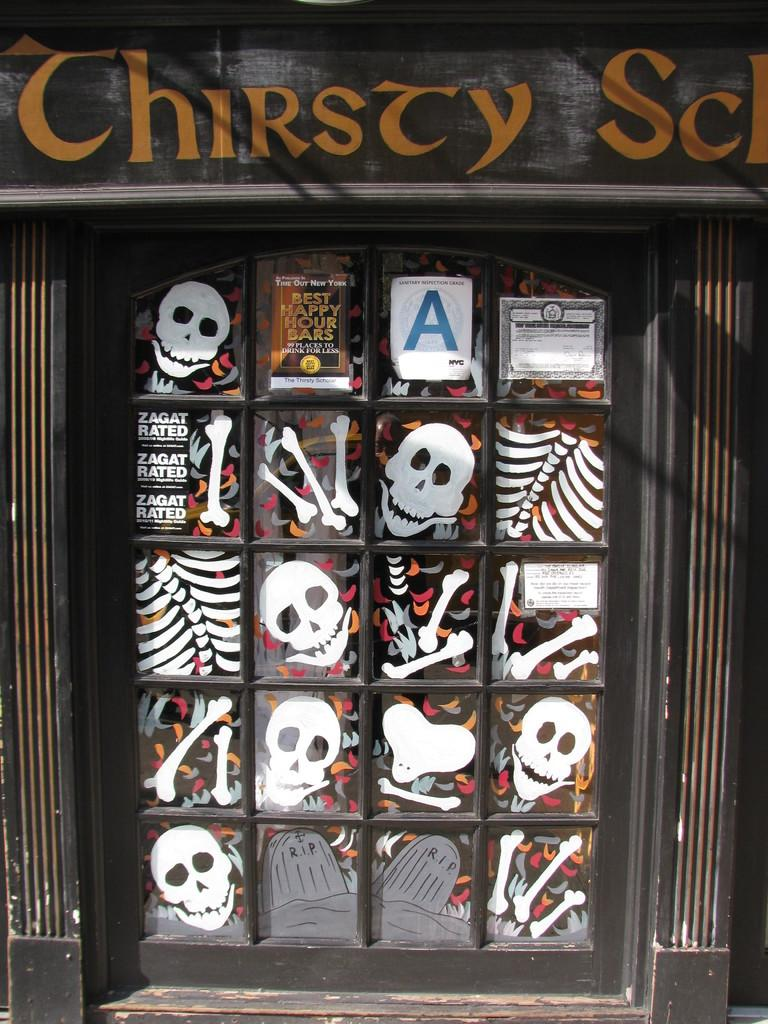What type of design can be seen on the glass window in the image? There is a skull design on the glass window in the image. Where is the glass window located in the image? The glass window is in the middle of the picture. What song is being sung by the skull in the image? There is no indication in the image that the skull is singing or that there is any song being sung. 